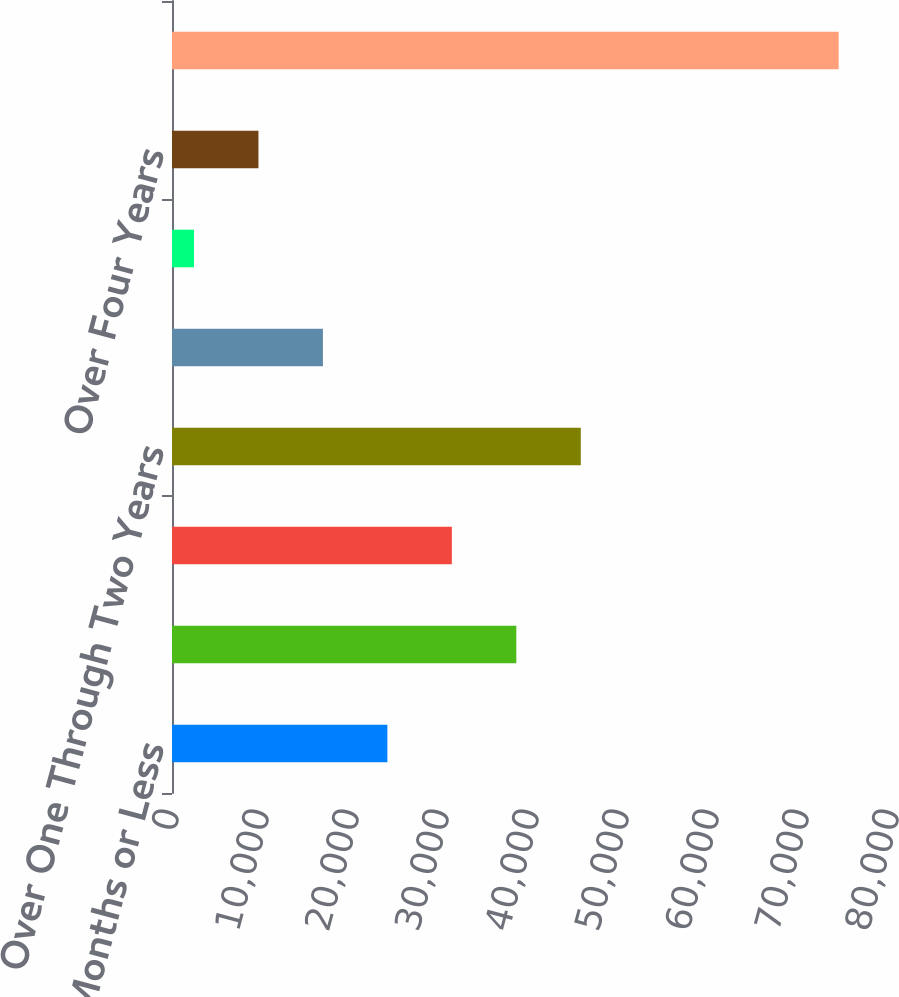Convert chart to OTSL. <chart><loc_0><loc_0><loc_500><loc_500><bar_chart><fcel>Three Months or Less<fcel>Over Three Through Six Months<fcel>Over Six Through Twelve Months<fcel>Over One Through Two Years<fcel>Over Two Through Three Years<fcel>Over Three Through Four Years<fcel>Over Four Years<fcel>Total<nl><fcel>23931.6<fcel>38258<fcel>31094.8<fcel>45421.2<fcel>16768.4<fcel>2442<fcel>9605.2<fcel>74074<nl></chart> 